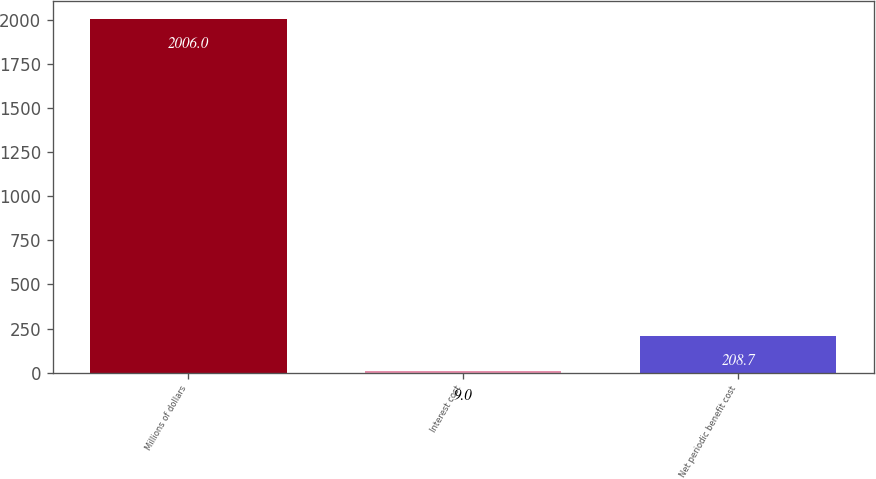<chart> <loc_0><loc_0><loc_500><loc_500><bar_chart><fcel>Millions of dollars<fcel>Interest cost<fcel>Net periodic benefit cost<nl><fcel>2006<fcel>9<fcel>208.7<nl></chart> 